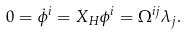<formula> <loc_0><loc_0><loc_500><loc_500>0 = { \dot { \phi } ^ { i } } = { X _ { H } } \phi ^ { i } = \Omega ^ { i j } \lambda _ { j } .</formula> 